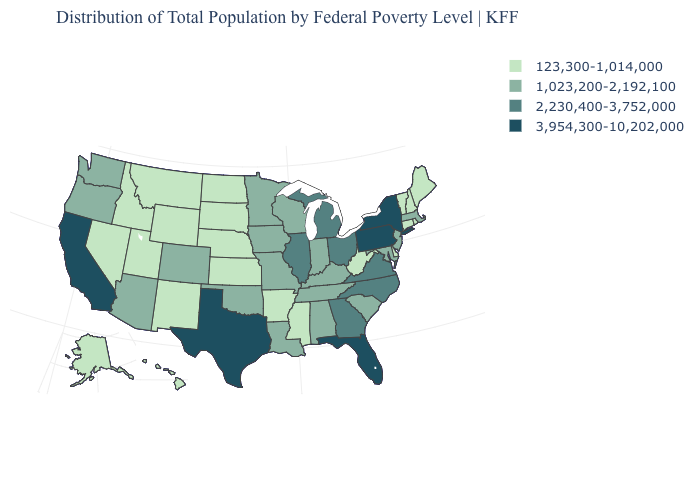What is the value of Hawaii?
Answer briefly. 123,300-1,014,000. What is the value of Mississippi?
Write a very short answer. 123,300-1,014,000. Which states have the lowest value in the USA?
Keep it brief. Alaska, Arkansas, Connecticut, Delaware, Hawaii, Idaho, Kansas, Maine, Mississippi, Montana, Nebraska, Nevada, New Hampshire, New Mexico, North Dakota, Rhode Island, South Dakota, Utah, Vermont, West Virginia, Wyoming. Name the states that have a value in the range 1,023,200-2,192,100?
Write a very short answer. Alabama, Arizona, Colorado, Indiana, Iowa, Kentucky, Louisiana, Maryland, Massachusetts, Minnesota, Missouri, New Jersey, Oklahoma, Oregon, South Carolina, Tennessee, Washington, Wisconsin. Which states have the lowest value in the USA?
Write a very short answer. Alaska, Arkansas, Connecticut, Delaware, Hawaii, Idaho, Kansas, Maine, Mississippi, Montana, Nebraska, Nevada, New Hampshire, New Mexico, North Dakota, Rhode Island, South Dakota, Utah, Vermont, West Virginia, Wyoming. Does Rhode Island have a lower value than Missouri?
Give a very brief answer. Yes. Name the states that have a value in the range 1,023,200-2,192,100?
Be succinct. Alabama, Arizona, Colorado, Indiana, Iowa, Kentucky, Louisiana, Maryland, Massachusetts, Minnesota, Missouri, New Jersey, Oklahoma, Oregon, South Carolina, Tennessee, Washington, Wisconsin. What is the lowest value in the USA?
Give a very brief answer. 123,300-1,014,000. What is the highest value in states that border Wisconsin?
Write a very short answer. 2,230,400-3,752,000. What is the value of Massachusetts?
Write a very short answer. 1,023,200-2,192,100. What is the lowest value in the Northeast?
Give a very brief answer. 123,300-1,014,000. What is the highest value in the Northeast ?
Answer briefly. 3,954,300-10,202,000. Name the states that have a value in the range 123,300-1,014,000?
Answer briefly. Alaska, Arkansas, Connecticut, Delaware, Hawaii, Idaho, Kansas, Maine, Mississippi, Montana, Nebraska, Nevada, New Hampshire, New Mexico, North Dakota, Rhode Island, South Dakota, Utah, Vermont, West Virginia, Wyoming. Among the states that border Idaho , does Oregon have the highest value?
Give a very brief answer. Yes. What is the value of Texas?
Quick response, please. 3,954,300-10,202,000. 